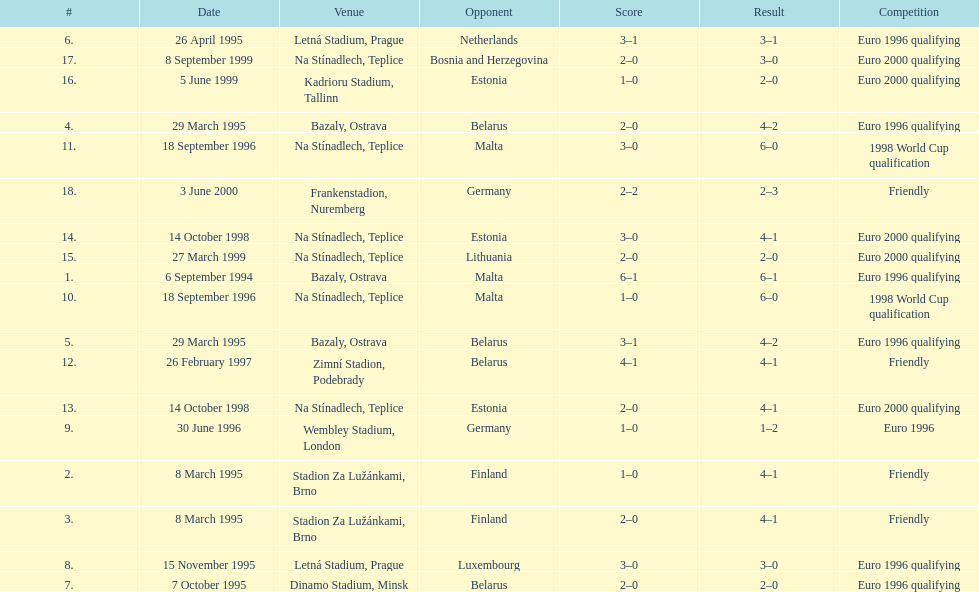List the opponents which are under the friendly competition. Finland, Belarus, Germany. 